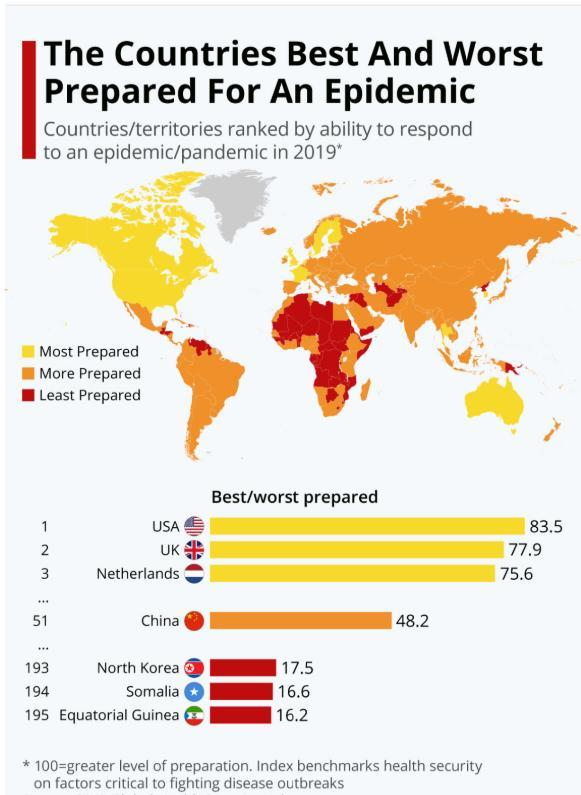Which country was more prepared for a pandemic in 2019 among the given countries?
Answer the question with a short phrase. China Which country was least prepared for a pandemic in 2019 other than North Korea & Equatorial Guinea? Somalia Which country was most prepared for a pandemic in 2019 other than USA & UK? Netherlands 